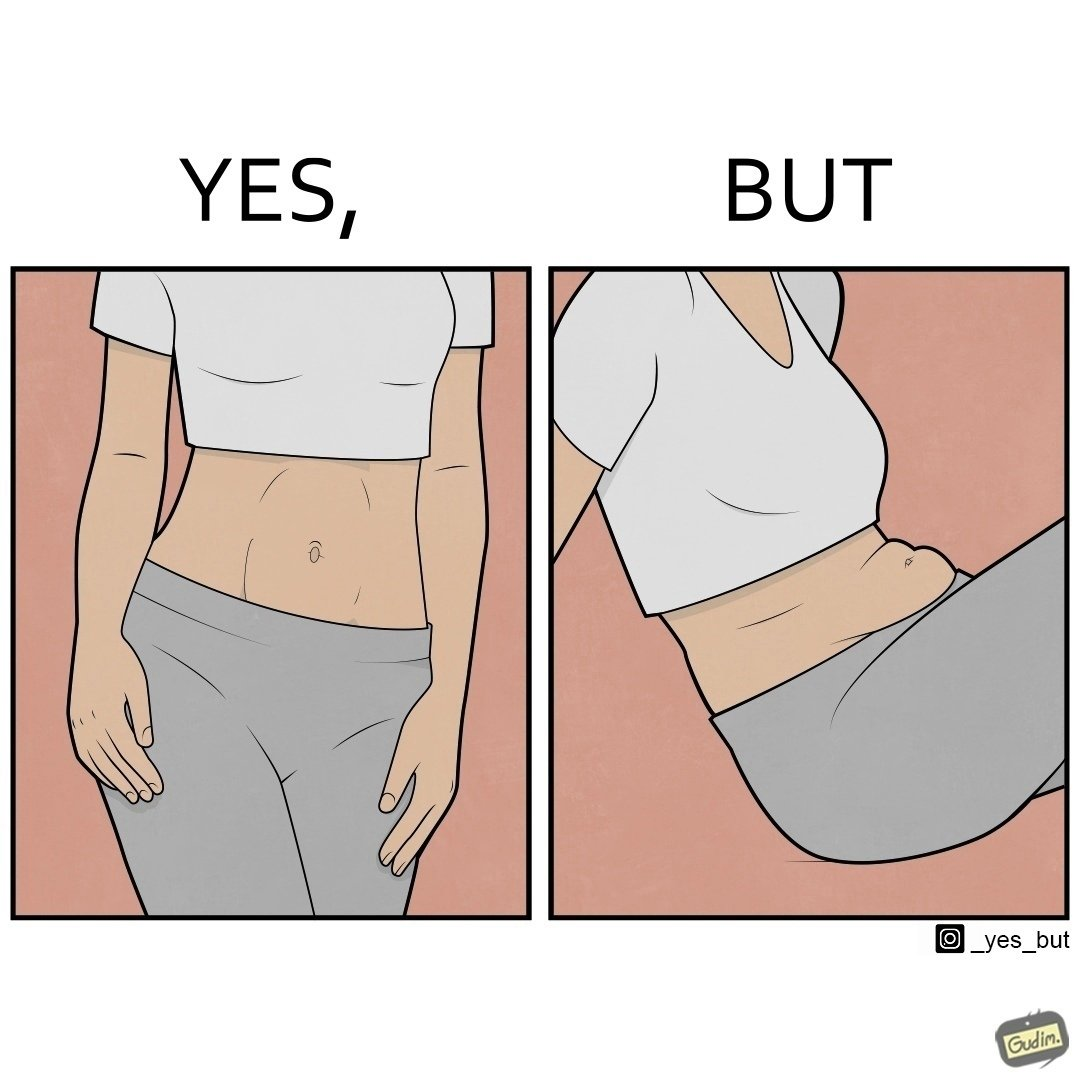What is the satirical meaning behind this image? the image is funny, as from the front, the woman is apparently slim, but she looks chubby from the side. 